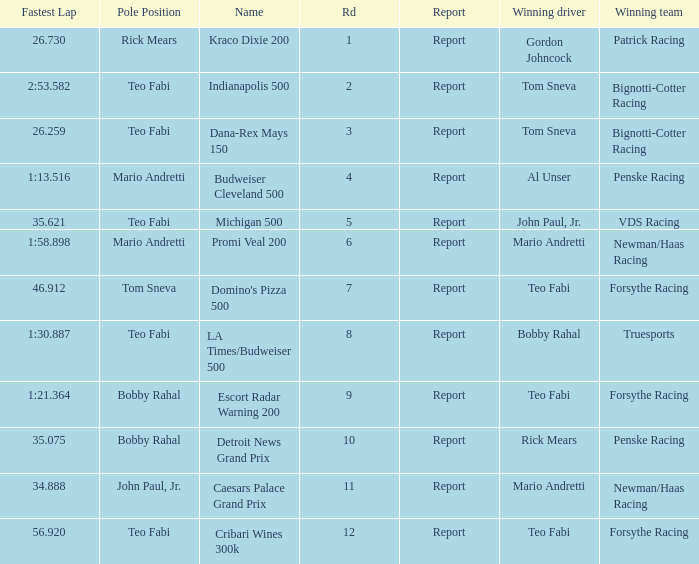Write the full table. {'header': ['Fastest Lap', 'Pole Position', 'Name', 'Rd', 'Report', 'Winning driver', 'Winning team'], 'rows': [['26.730', 'Rick Mears', 'Kraco Dixie 200', '1', 'Report', 'Gordon Johncock', 'Patrick Racing'], ['2:53.582', 'Teo Fabi', 'Indianapolis 500', '2', 'Report', 'Tom Sneva', 'Bignotti-Cotter Racing'], ['26.259', 'Teo Fabi', 'Dana-Rex Mays 150', '3', 'Report', 'Tom Sneva', 'Bignotti-Cotter Racing'], ['1:13.516', 'Mario Andretti', 'Budweiser Cleveland 500', '4', 'Report', 'Al Unser', 'Penske Racing'], ['35.621', 'Teo Fabi', 'Michigan 500', '5', 'Report', 'John Paul, Jr.', 'VDS Racing'], ['1:58.898', 'Mario Andretti', 'Promi Veal 200', '6', 'Report', 'Mario Andretti', 'Newman/Haas Racing'], ['46.912', 'Tom Sneva', "Domino's Pizza 500", '7', 'Report', 'Teo Fabi', 'Forsythe Racing'], ['1:30.887', 'Teo Fabi', 'LA Times/Budweiser 500', '8', 'Report', 'Bobby Rahal', 'Truesports'], ['1:21.364', 'Bobby Rahal', 'Escort Radar Warning 200', '9', 'Report', 'Teo Fabi', 'Forsythe Racing'], ['35.075', 'Bobby Rahal', 'Detroit News Grand Prix', '10', 'Report', 'Rick Mears', 'Penske Racing'], ['34.888', 'John Paul, Jr.', 'Caesars Palace Grand Prix', '11', 'Report', 'Mario Andretti', 'Newman/Haas Racing'], ['56.920', 'Teo Fabi', 'Cribari Wines 300k', '12', 'Report', 'Teo Fabi', 'Forsythe Racing']]} Which Rd took place at the Indianapolis 500? 2.0. 